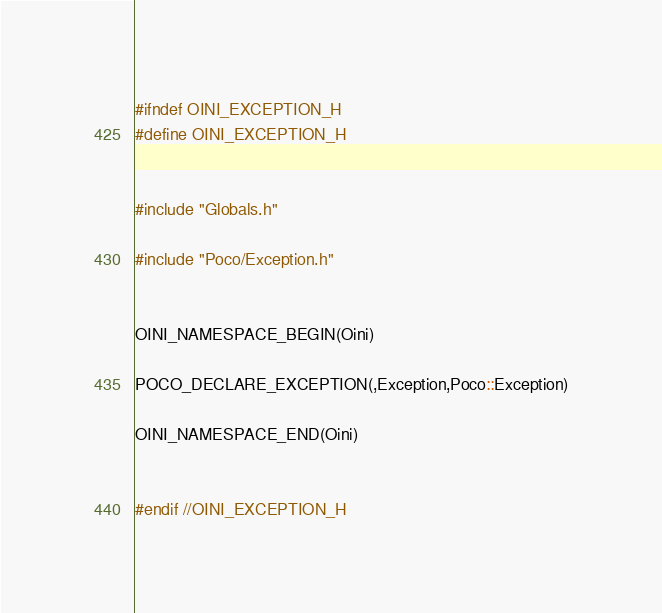Convert code to text. <code><loc_0><loc_0><loc_500><loc_500><_C_>
#ifndef OINI_EXCEPTION_H
#define OINI_EXCEPTION_H


#include "Globals.h"

#include "Poco/Exception.h"


OINI_NAMESPACE_BEGIN(Oini)

POCO_DECLARE_EXCEPTION(,Exception,Poco::Exception)

OINI_NAMESPACE_END(Oini)


#endif //OINI_EXCEPTION_H
</code> 